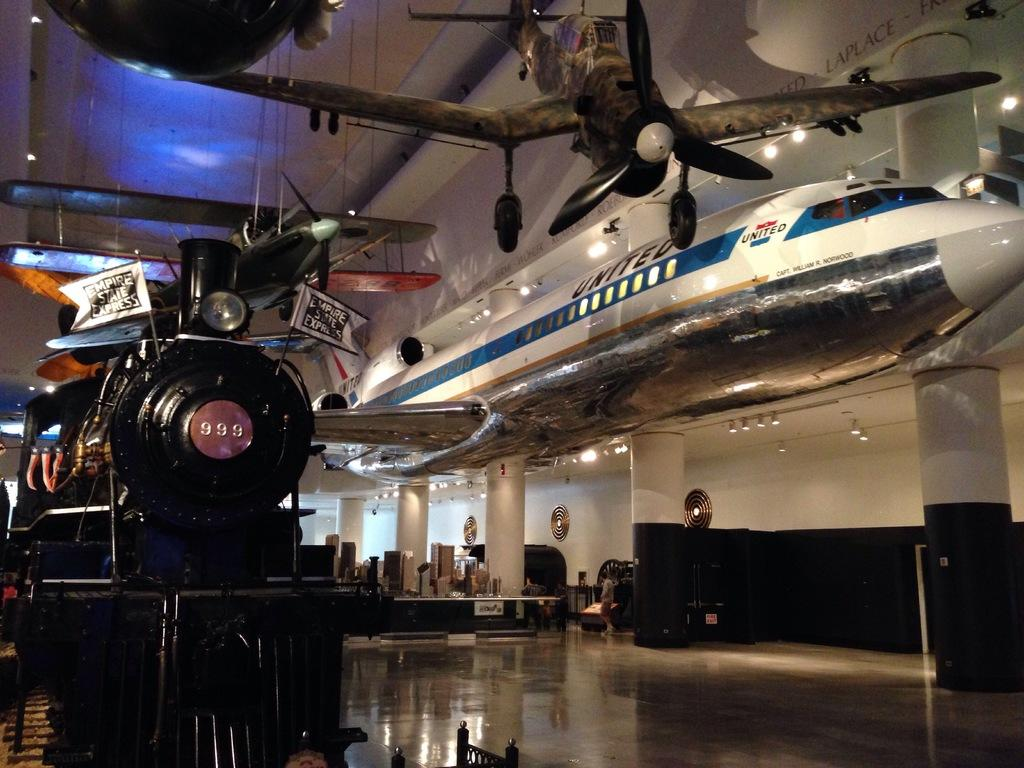<image>
Offer a succinct explanation of the picture presented. a museum with a train and an airplane in it 